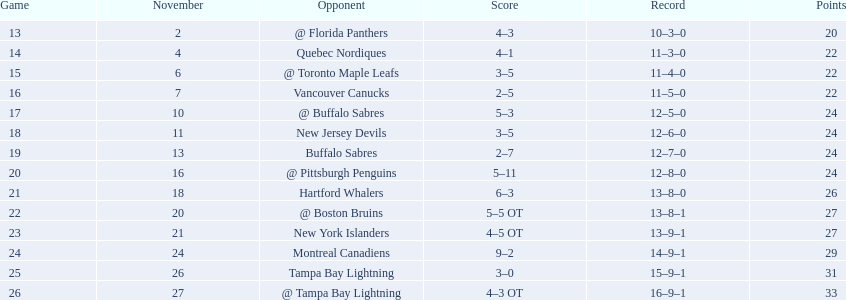What are the squads in the atlantic division? Quebec Nordiques, Vancouver Canucks, New Jersey Devils, Buffalo Sabres, Hartford Whalers, New York Islanders, Montreal Canadiens, Tampa Bay Lightning. Could you help me parse every detail presented in this table? {'header': ['Game', 'November', 'Opponent', 'Score', 'Record', 'Points'], 'rows': [['13', '2', '@ Florida Panthers', '4–3', '10–3–0', '20'], ['14', '4', 'Quebec Nordiques', '4–1', '11–3–0', '22'], ['15', '6', '@ Toronto Maple Leafs', '3–5', '11–4–0', '22'], ['16', '7', 'Vancouver Canucks', '2–5', '11–5–0', '22'], ['17', '10', '@ Buffalo Sabres', '5–3', '12–5–0', '24'], ['18', '11', 'New Jersey Devils', '3–5', '12–6–0', '24'], ['19', '13', 'Buffalo Sabres', '2–7', '12–7–0', '24'], ['20', '16', '@ Pittsburgh Penguins', '5–11', '12–8–0', '24'], ['21', '18', 'Hartford Whalers', '6–3', '13–8–0', '26'], ['22', '20', '@ Boston Bruins', '5–5 OT', '13–8–1', '27'], ['23', '21', 'New York Islanders', '4–5 OT', '13–9–1', '27'], ['24', '24', 'Montreal Canadiens', '9–2', '14–9–1', '29'], ['25', '26', 'Tampa Bay Lightning', '3–0', '15–9–1', '31'], ['26', '27', '@ Tampa Bay Lightning', '4–3 OT', '16–9–1', '33']]} Which of those tallied fewer points than the philadelphia flyers? Tampa Bay Lightning. 